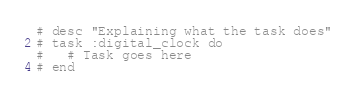<code> <loc_0><loc_0><loc_500><loc_500><_Ruby_># desc "Explaining what the task does"
# task :digital_clock do
#   # Task goes here
# end
</code> 